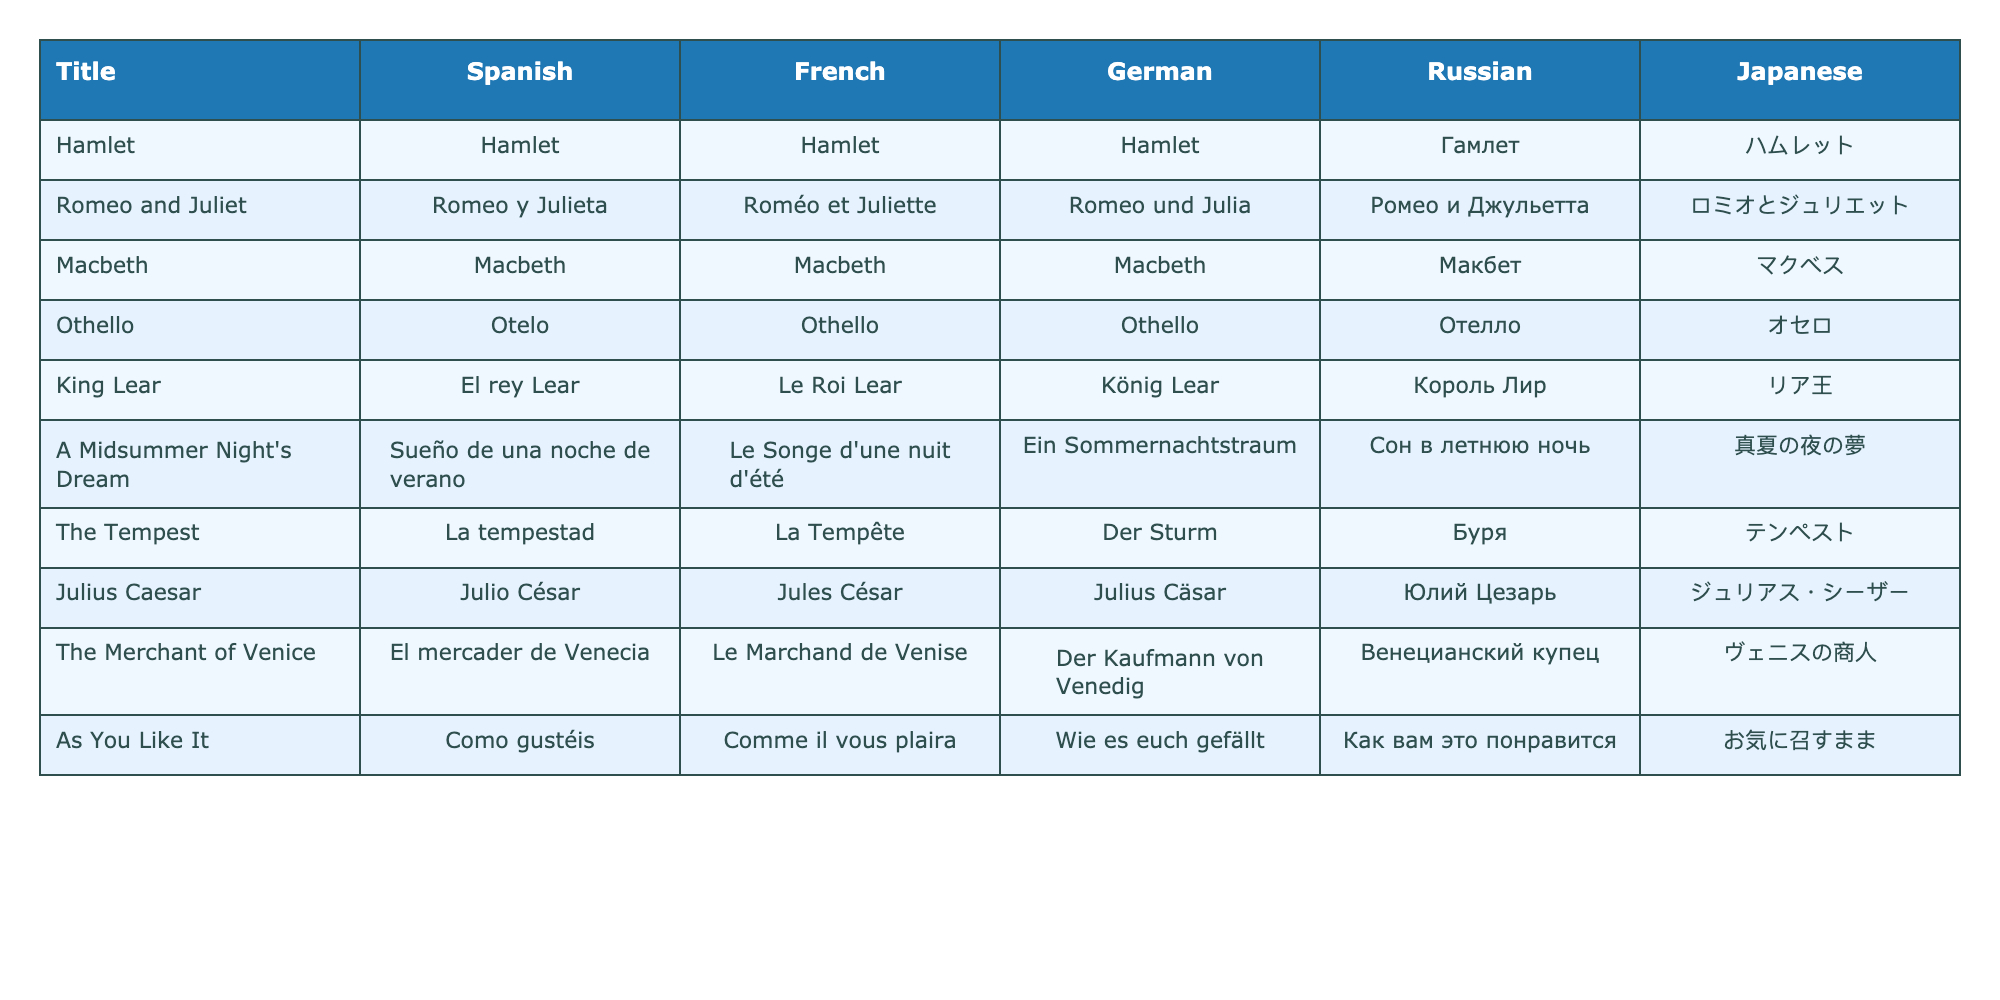What is the Spanish title for "The Tempest"? The table lists the Spanish titles for each play, and for "The Tempest," it shows "La tempestad."
Answer: La tempestad Which play has the same title in Spanish, French, and German? By examining the titles in the table, "Macbeth" is shown to have the same title across Spanish, French, and German columns.
Answer: Macbeth Is "Hamlet" translated differently in Japanese than in Russian? Looking at the table, "Hamlet" is also "Hamlet" in Russian, but it is "ハムレット" in Japanese, which confirms they are translated differently.
Answer: Yes How many of the plays have the same title across all five languages? By reviewing the table, "Hamlet" and "Macbeth" show the same title in all columns. In total, there are 2 plays with the same title across all five languages.
Answer: 2 What is the French title for "A Midsummer Night's Dream"? The table indicates that the French title for "A Midsummer Night's Dream" is "Le Songe d'une nuit d'été."
Answer: Le Songe d'une nuit d'été Which play has the most distinct translations among the languages listed? Analyzing the translations, "King Lear" has unique titles across all languages, indicating that it has the most distinct translations.
Answer: King Lear Are there any plays that share the same translated title in both German and Russian? In the table, "Othello" and "Macbeth" have the same titles in both German and Russian, which confirms that there are plays sharing translated titles.
Answer: Yes What is the total count of plays translated into Japanese? The table lists nine different plays with translations into Japanese, confirming the total count of translations.
Answer: 9 Which play's title in Russian translates to "Julio César" in Spanish? The table indicates that "Julius Caesar" is translated as "Юлий Цезарь" in Russian, and its corresponding Spanish translation is "Julio César."
Answer: Julius Caesar Is "Romeo and Juliet" the same title in all languages? Checking the titles in the table, "Romeo and Juliet" does not remain the same; in Spanish, it is "Romeo y Julieta," indicating various translations.
Answer: No 